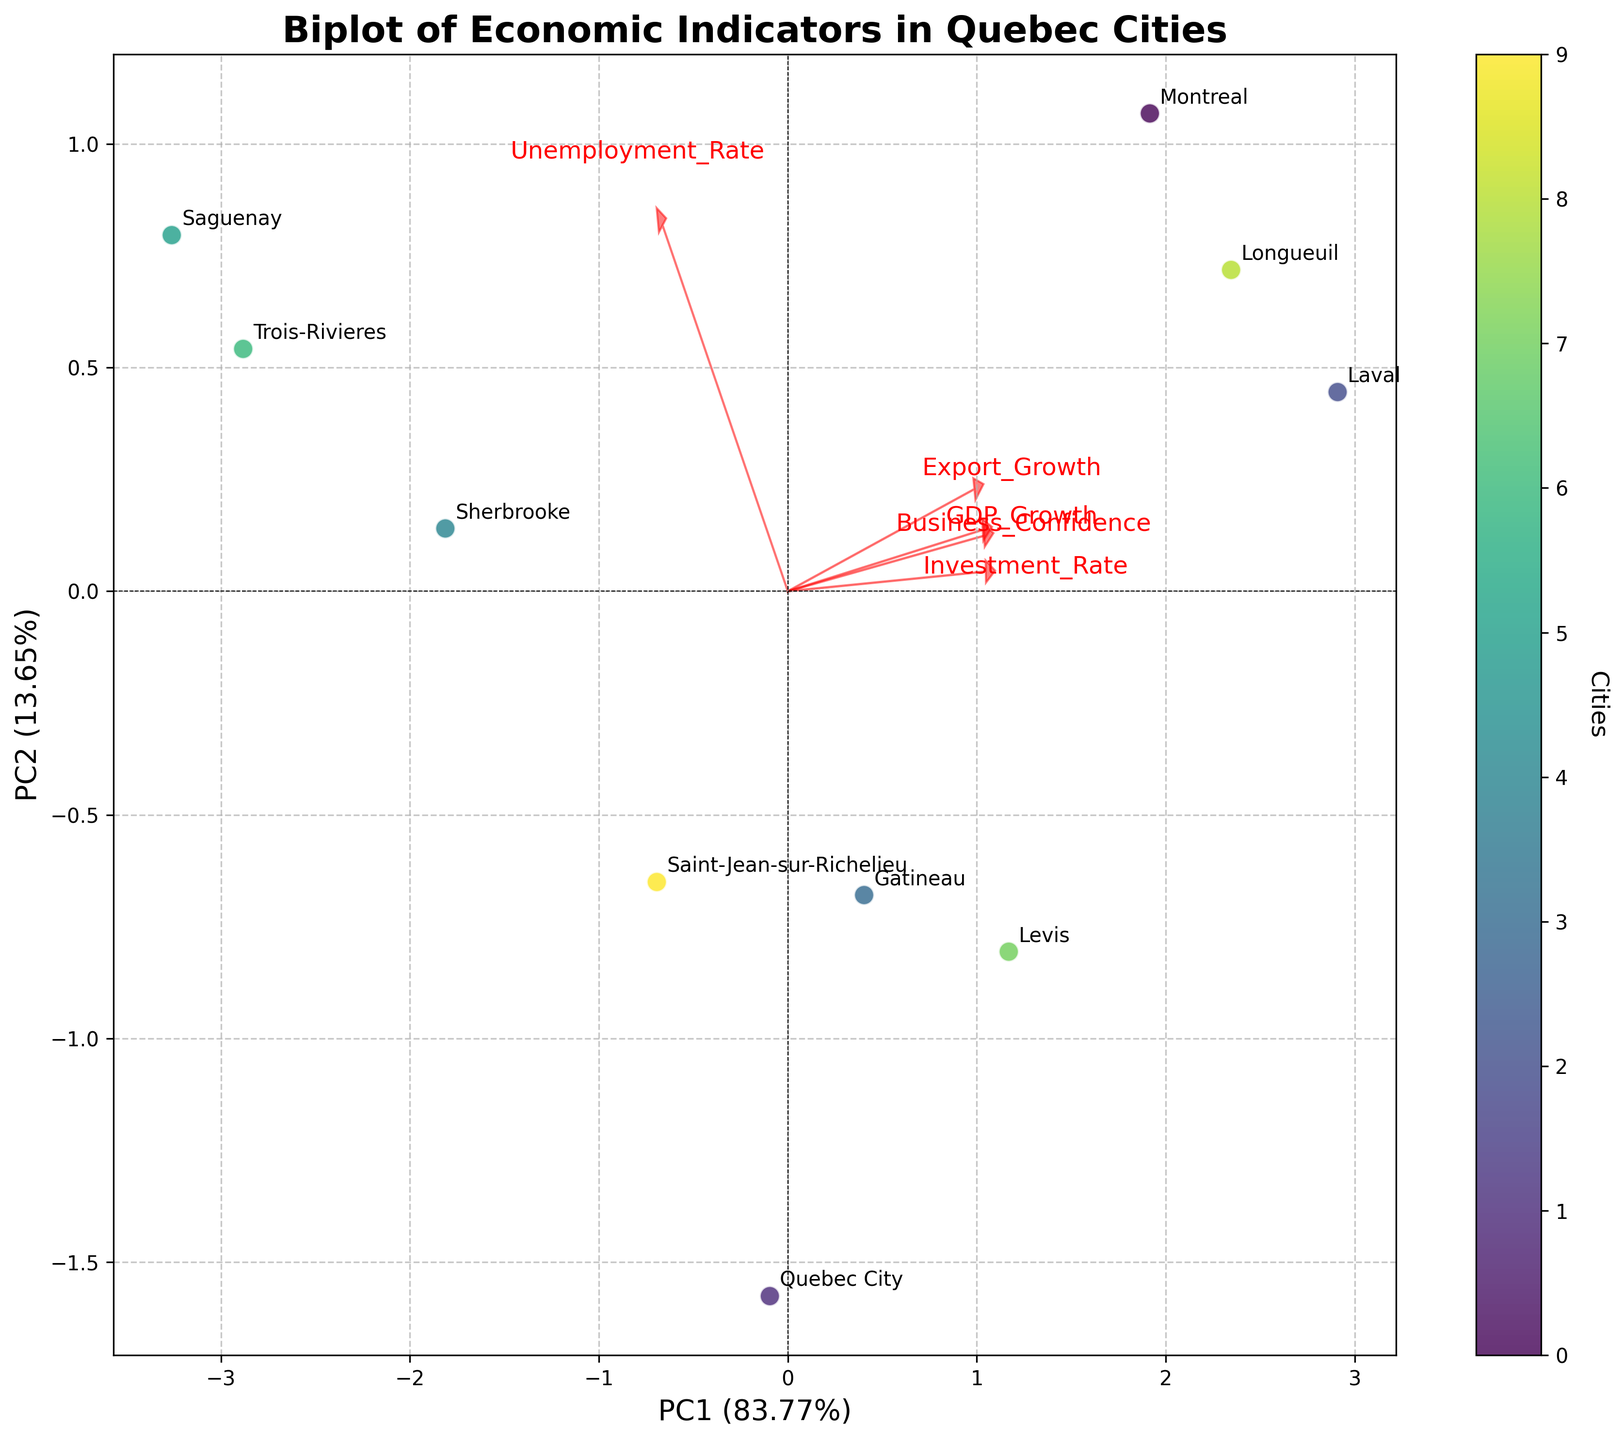What does the title of the figure indicate? The title of the figure is displayed at the top, and it usually provides an overview of what the figure is about. Here, it indicates that the biplot presents economic indicators for different cities in Quebec.
Answer: Biplot of Economic Indicators in Quebec Cities How many cities are represented in the plot? Each city is represented by a point labeled with the city name in the biplot. By counting these labels, you can determine the number of cities.
Answer: 10 Which city appears to have the highest Business Confidence score based on the biplot? The length and direction of the Business Confidence arrow can indicate which city is aligned most closely with it. By examining the plot, find the city whose point is furthest in the direction of this vector.
Answer: Laval From the biplot, what can you infer about the relationship between GDP Growth and Unemployment Rate? The vectors representing GDP Growth and Unemployment Rate are plotted. Their angles and directions relative to each other can indicate their correlation: a small angle suggests a positive correlation, a 90-degree angle suggests no correlation, and an opposing direction suggests a negative correlation.
Answer: Likely positive correlation Comparing Montreal and Quebec City, which city has a higher Investment Rate? Find the points corresponding to Montreal and Quebec City and see their position relative to the Investment Rate vector. The city whose point is further in the direction of the vector will have a higher Investment Rate.
Answer: Montreal Which economic indicator contributes most to the first principal component (PC1)? The direction and length of the arrows corresponding to each economic indicator determine their contribution to PC1. The longer the arrow in the direction of PC1, the greater the contribution.
Answer: GDP Growth Is there any city with an Export Growth rate strongly aligned with PC2? Check the direction and length of the Export Growth arrow concerning PC2. Identify any city whose points are along this direction, indicating strong alignment with PC2.
Answer: None observed strongly aligned with PC2 Which cities have similar economic profiles based on the biplot? Cities that have points located close to each other in the biplot typically have similar economic profiles. Identify such clusters of points.
Answer: Laval and Longueuil What is the explained variance of PC1 and PC2? The explained variance for PC1 and PC2 is usually displayed along the axis labels. This percentage indicates how much of the data's variability is captured by each component.
Answer: PC1 (explained variance) is approximately 43%, and PC2 is approximately 27% Is there a negative relationship between any two economic indicators? Check for pairs of arrows that point in nearly opposite directions (180 degrees apart). This would suggest a negative relationship between the respective indicators.
Answer: Potential negative relationship between Business Confidence and Unemployment Rate 